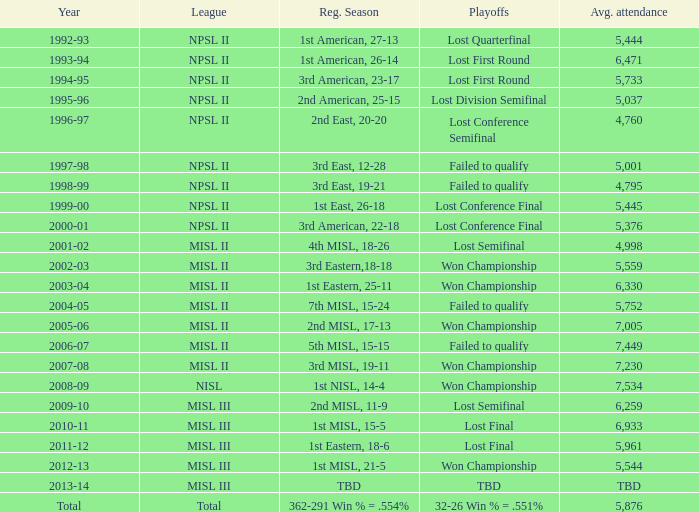When was the year that had an average attendance of 5,445? 1999-00. 